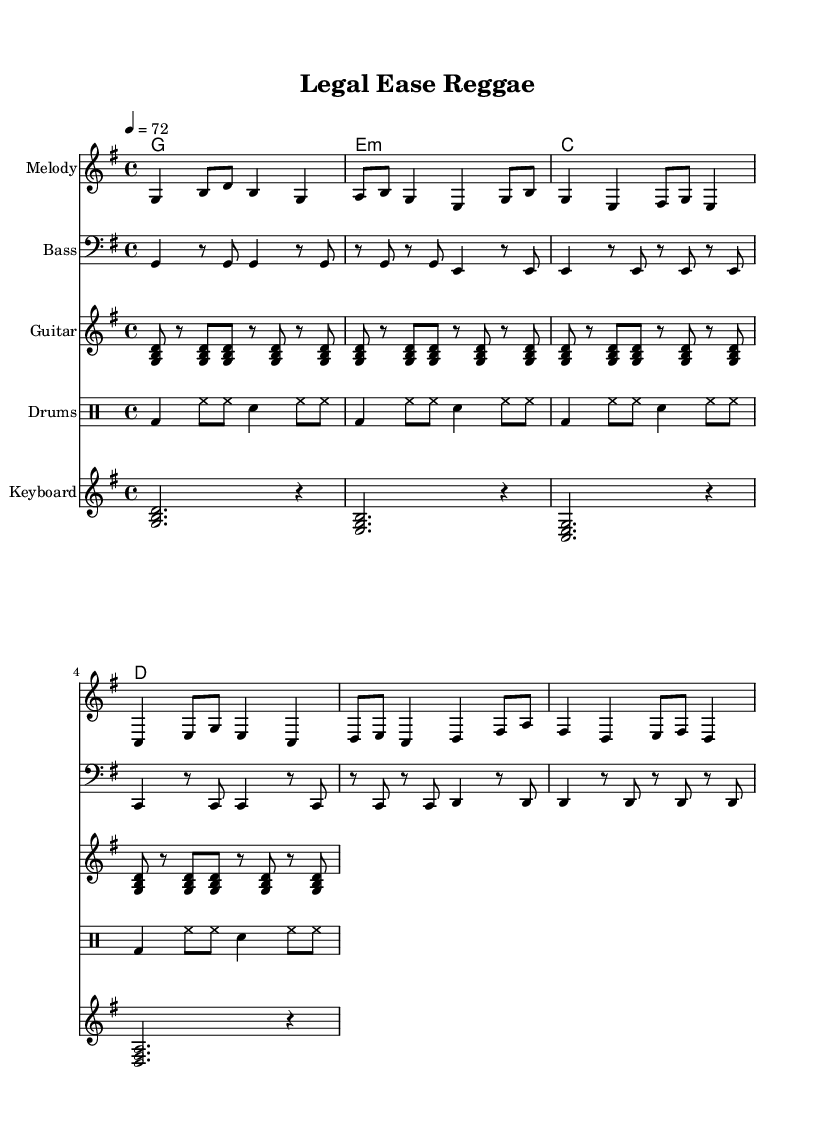What is the key signature of this music? The key signature is G major, which has one sharp (F#). This is indicated at the beginning of the staff where the key signature is placed.
Answer: G major What is the time signature of the piece? The time signature is 4/4, as shown by the fraction at the beginning of the score. This means there are four beats in a measure and the quarter note gets one beat.
Answer: 4/4 What is the tempo marking for this piece? The tempo marking is indicated as 4 = 72, meaning there are 72 beats per minute with a quarter note receiving a beat. It is a moderate tempo suitable for a relaxing vibe.
Answer: 72 How many measures are present in the melody section? The melody section consists of six measures, easily counted by the vertical lines indicating the bar lines within the staff.
Answer: 6 What is the primary instrument indicated for the melody? The primary instrument indicated for the melody is simply labeled as "Melody" on the staff header, which refers to the notated melodic line that is independent of any specific instrument.
Answer: Melody Which rhythmic pattern is used for the drum section? The drum section features a basic pattern with bass drum and hi-hat, as indicated by their respective notations shown in a consistent 4/4 rhythm.
Answer: Bass and hi-hat What is the structure of the chords played in the keyboard section? The keyboard section follows a chord progression of G, E minor, C, D, indicated by the chord symbols written above the staff. Each chord is played for a whole note followed by a rest.
Answer: G, E minor, C, D 